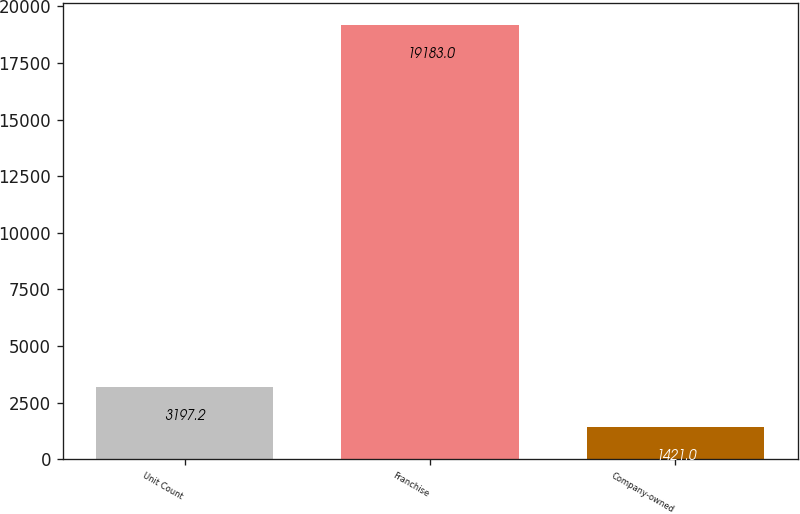Convert chart to OTSL. <chart><loc_0><loc_0><loc_500><loc_500><bar_chart><fcel>Unit Count<fcel>Franchise<fcel>Company-owned<nl><fcel>3197.2<fcel>19183<fcel>1421<nl></chart> 